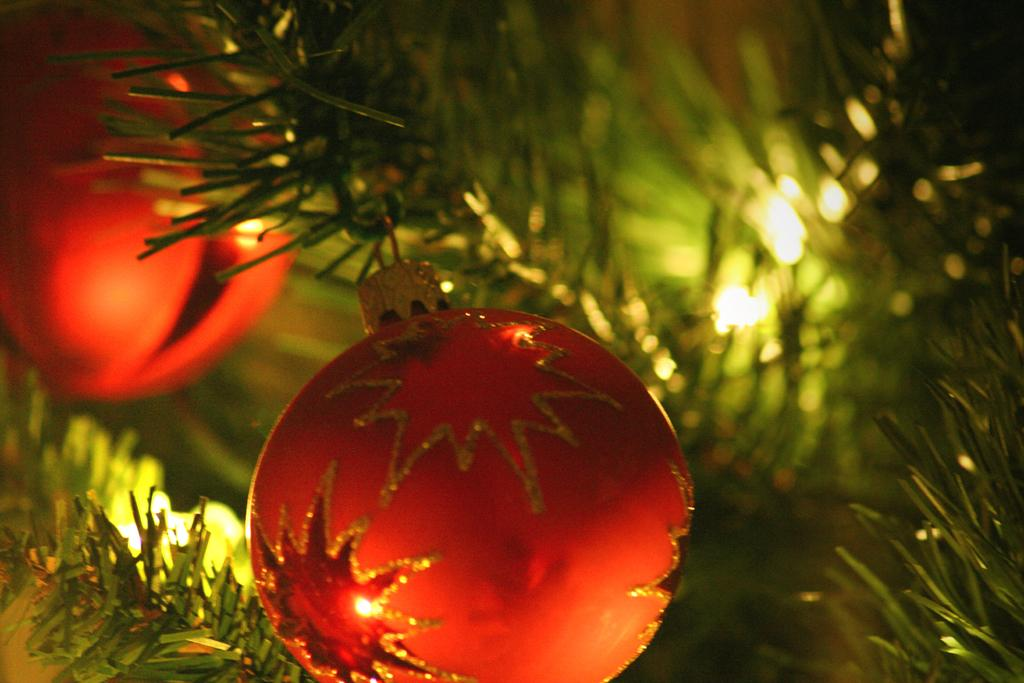What is the main object in the picture? There is a Christmas tree in the picture. What type of decorations can be seen on the Christmas tree? There are decorative balls on the Christmas tree. What type of powder can be seen falling from the Christmas tree in the image? There is no powder falling from the Christmas tree in the image. What sound can be heard coming from the Christmas tree in the image? There is no sound coming from the Christmas tree in the image. 